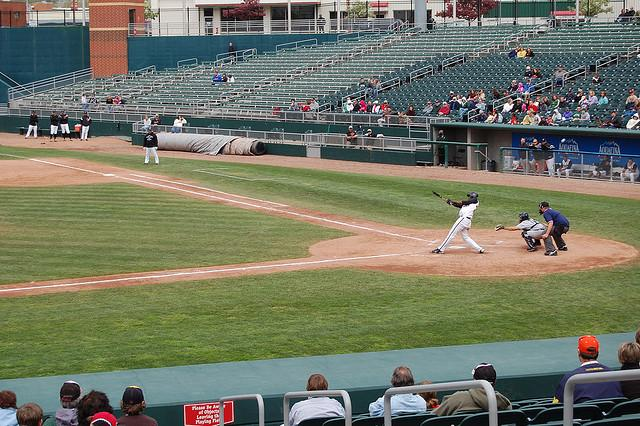How many players in baseball team? nine 